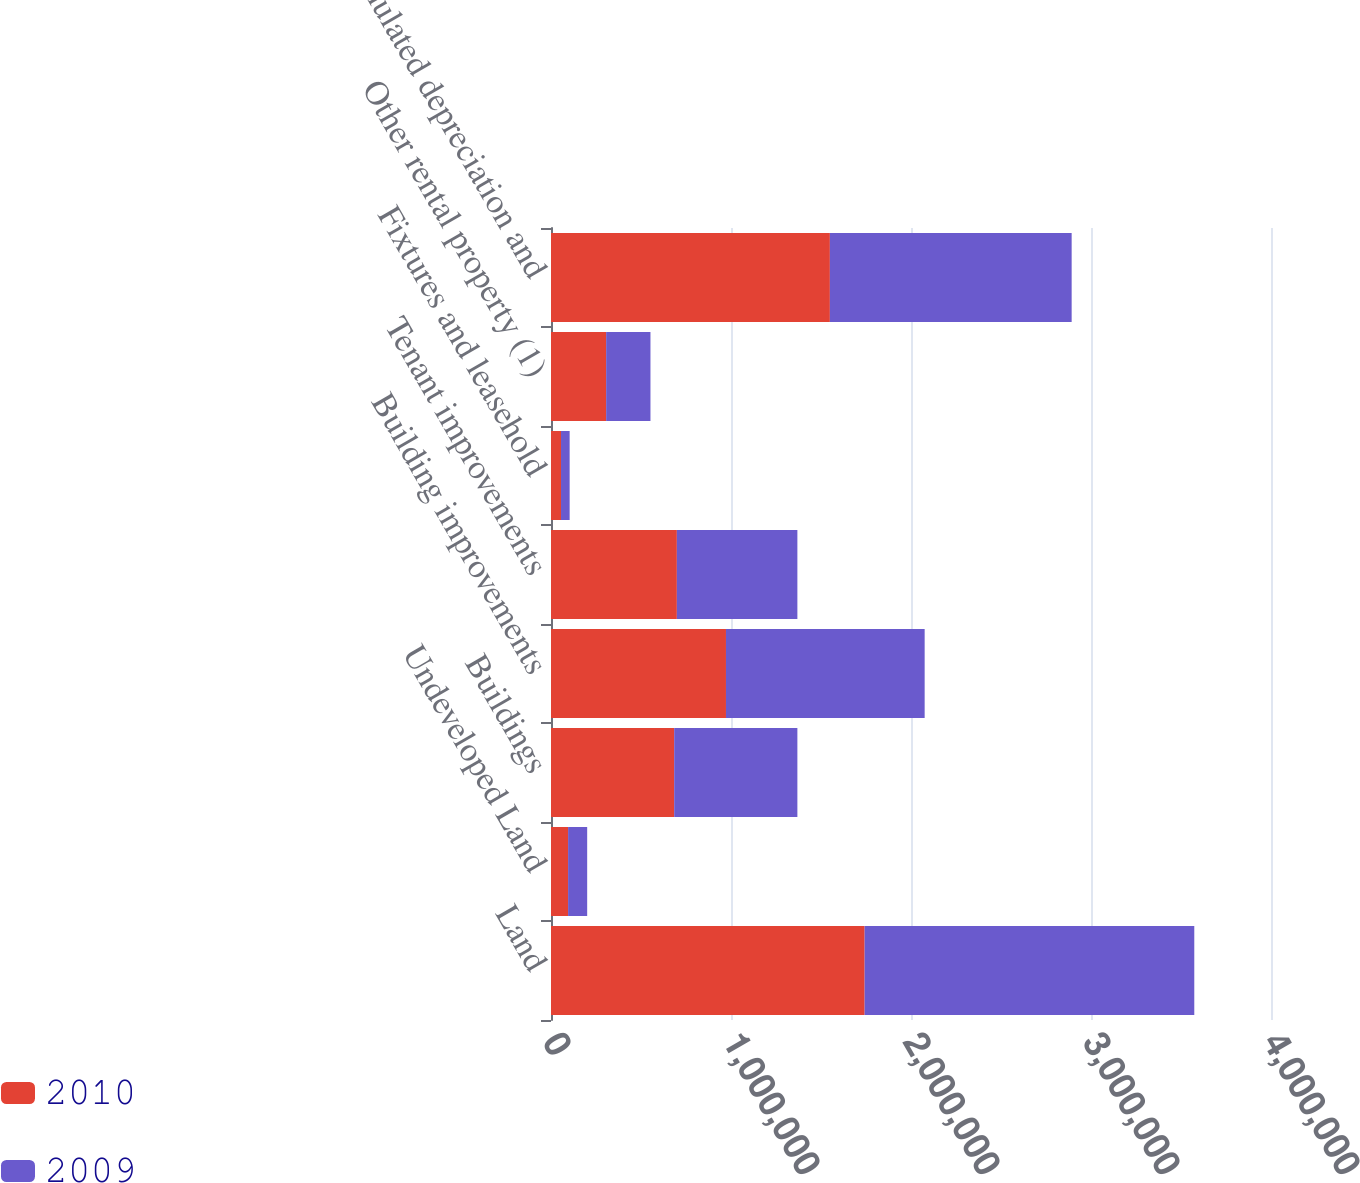<chart> <loc_0><loc_0><loc_500><loc_500><stacked_bar_chart><ecel><fcel>Land<fcel>Undeveloped Land<fcel>Buildings<fcel>Building improvements<fcel>Tenant improvements<fcel>Fixtures and leasehold<fcel>Other rental property (1)<fcel>Accumulated depreciation and<nl><fcel>2010<fcel>1.74242e+06<fcel>94923<fcel>684391<fcel>972086<fcel>699242<fcel>55611<fcel>306322<fcel>1.54938e+06<nl><fcel>2009<fcel>1.83137e+06<fcel>106054<fcel>684391<fcel>1.1038e+06<fcel>669540<fcel>48008<fcel>246217<fcel>1.34315e+06<nl></chart> 